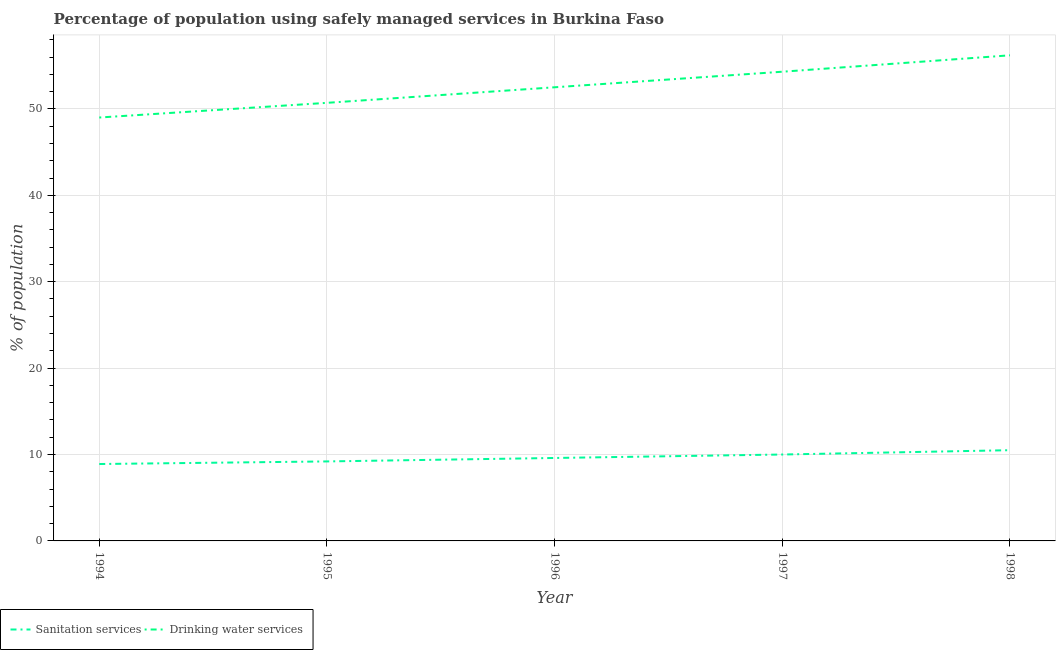How many different coloured lines are there?
Make the answer very short. 2. Across all years, what is the minimum percentage of population who used drinking water services?
Keep it short and to the point. 49. In which year was the percentage of population who used sanitation services maximum?
Your response must be concise. 1998. In which year was the percentage of population who used drinking water services minimum?
Your response must be concise. 1994. What is the total percentage of population who used sanitation services in the graph?
Your answer should be compact. 48.2. What is the difference between the percentage of population who used sanitation services in 1997 and that in 1998?
Offer a very short reply. -0.5. What is the difference between the percentage of population who used drinking water services in 1994 and the percentage of population who used sanitation services in 1995?
Your response must be concise. 39.8. What is the average percentage of population who used sanitation services per year?
Your answer should be compact. 9.64. In the year 1994, what is the difference between the percentage of population who used sanitation services and percentage of population who used drinking water services?
Provide a short and direct response. -40.1. What is the ratio of the percentage of population who used sanitation services in 1994 to that in 1995?
Your answer should be compact. 0.97. Is the percentage of population who used sanitation services in 1997 less than that in 1998?
Ensure brevity in your answer.  Yes. What is the difference between the highest and the second highest percentage of population who used drinking water services?
Offer a very short reply. 1.9. What is the difference between the highest and the lowest percentage of population who used drinking water services?
Offer a terse response. 7.2. In how many years, is the percentage of population who used sanitation services greater than the average percentage of population who used sanitation services taken over all years?
Ensure brevity in your answer.  2. Is the sum of the percentage of population who used drinking water services in 1994 and 1995 greater than the maximum percentage of population who used sanitation services across all years?
Keep it short and to the point. Yes. Does the percentage of population who used sanitation services monotonically increase over the years?
Provide a short and direct response. Yes. Is the percentage of population who used drinking water services strictly greater than the percentage of population who used sanitation services over the years?
Your response must be concise. Yes. Is the percentage of population who used drinking water services strictly less than the percentage of population who used sanitation services over the years?
Ensure brevity in your answer.  No. How many lines are there?
Offer a terse response. 2. What is the difference between two consecutive major ticks on the Y-axis?
Provide a short and direct response. 10. Are the values on the major ticks of Y-axis written in scientific E-notation?
Your answer should be very brief. No. Does the graph contain any zero values?
Offer a very short reply. No. Where does the legend appear in the graph?
Provide a short and direct response. Bottom left. How are the legend labels stacked?
Provide a succinct answer. Horizontal. What is the title of the graph?
Your answer should be very brief. Percentage of population using safely managed services in Burkina Faso. Does "International Tourists" appear as one of the legend labels in the graph?
Give a very brief answer. No. What is the label or title of the X-axis?
Make the answer very short. Year. What is the label or title of the Y-axis?
Your response must be concise. % of population. What is the % of population in Sanitation services in 1994?
Provide a succinct answer. 8.9. What is the % of population in Drinking water services in 1994?
Offer a terse response. 49. What is the % of population in Drinking water services in 1995?
Make the answer very short. 50.7. What is the % of population in Sanitation services in 1996?
Your response must be concise. 9.6. What is the % of population in Drinking water services in 1996?
Ensure brevity in your answer.  52.5. What is the % of population of Sanitation services in 1997?
Your response must be concise. 10. What is the % of population of Drinking water services in 1997?
Your response must be concise. 54.3. What is the % of population of Drinking water services in 1998?
Provide a short and direct response. 56.2. Across all years, what is the maximum % of population in Sanitation services?
Keep it short and to the point. 10.5. Across all years, what is the maximum % of population in Drinking water services?
Provide a succinct answer. 56.2. What is the total % of population of Sanitation services in the graph?
Keep it short and to the point. 48.2. What is the total % of population in Drinking water services in the graph?
Your answer should be very brief. 262.7. What is the difference between the % of population of Drinking water services in 1994 and that in 1995?
Provide a short and direct response. -1.7. What is the difference between the % of population of Drinking water services in 1994 and that in 1997?
Ensure brevity in your answer.  -5.3. What is the difference between the % of population in Sanitation services in 1995 and that in 1997?
Offer a terse response. -0.8. What is the difference between the % of population in Drinking water services in 1995 and that in 1997?
Your answer should be compact. -3.6. What is the difference between the % of population of Drinking water services in 1995 and that in 1998?
Give a very brief answer. -5.5. What is the difference between the % of population of Sanitation services in 1997 and that in 1998?
Provide a short and direct response. -0.5. What is the difference between the % of population of Sanitation services in 1994 and the % of population of Drinking water services in 1995?
Ensure brevity in your answer.  -41.8. What is the difference between the % of population of Sanitation services in 1994 and the % of population of Drinking water services in 1996?
Offer a very short reply. -43.6. What is the difference between the % of population of Sanitation services in 1994 and the % of population of Drinking water services in 1997?
Offer a very short reply. -45.4. What is the difference between the % of population in Sanitation services in 1994 and the % of population in Drinking water services in 1998?
Your response must be concise. -47.3. What is the difference between the % of population in Sanitation services in 1995 and the % of population in Drinking water services in 1996?
Your answer should be compact. -43.3. What is the difference between the % of population of Sanitation services in 1995 and the % of population of Drinking water services in 1997?
Your answer should be very brief. -45.1. What is the difference between the % of population in Sanitation services in 1995 and the % of population in Drinking water services in 1998?
Give a very brief answer. -47. What is the difference between the % of population in Sanitation services in 1996 and the % of population in Drinking water services in 1997?
Provide a succinct answer. -44.7. What is the difference between the % of population of Sanitation services in 1996 and the % of population of Drinking water services in 1998?
Keep it short and to the point. -46.6. What is the difference between the % of population of Sanitation services in 1997 and the % of population of Drinking water services in 1998?
Provide a short and direct response. -46.2. What is the average % of population in Sanitation services per year?
Your response must be concise. 9.64. What is the average % of population of Drinking water services per year?
Offer a terse response. 52.54. In the year 1994, what is the difference between the % of population in Sanitation services and % of population in Drinking water services?
Offer a terse response. -40.1. In the year 1995, what is the difference between the % of population of Sanitation services and % of population of Drinking water services?
Give a very brief answer. -41.5. In the year 1996, what is the difference between the % of population in Sanitation services and % of population in Drinking water services?
Keep it short and to the point. -42.9. In the year 1997, what is the difference between the % of population in Sanitation services and % of population in Drinking water services?
Provide a succinct answer. -44.3. In the year 1998, what is the difference between the % of population in Sanitation services and % of population in Drinking water services?
Give a very brief answer. -45.7. What is the ratio of the % of population of Sanitation services in 1994 to that in 1995?
Your answer should be compact. 0.97. What is the ratio of the % of population in Drinking water services in 1994 to that in 1995?
Provide a succinct answer. 0.97. What is the ratio of the % of population in Sanitation services in 1994 to that in 1996?
Keep it short and to the point. 0.93. What is the ratio of the % of population in Sanitation services in 1994 to that in 1997?
Make the answer very short. 0.89. What is the ratio of the % of population of Drinking water services in 1994 to that in 1997?
Keep it short and to the point. 0.9. What is the ratio of the % of population of Sanitation services in 1994 to that in 1998?
Give a very brief answer. 0.85. What is the ratio of the % of population of Drinking water services in 1994 to that in 1998?
Provide a succinct answer. 0.87. What is the ratio of the % of population in Drinking water services in 1995 to that in 1996?
Offer a very short reply. 0.97. What is the ratio of the % of population of Sanitation services in 1995 to that in 1997?
Your answer should be compact. 0.92. What is the ratio of the % of population of Drinking water services in 1995 to that in 1997?
Ensure brevity in your answer.  0.93. What is the ratio of the % of population in Sanitation services in 1995 to that in 1998?
Your answer should be compact. 0.88. What is the ratio of the % of population of Drinking water services in 1995 to that in 1998?
Your answer should be compact. 0.9. What is the ratio of the % of population of Drinking water services in 1996 to that in 1997?
Offer a very short reply. 0.97. What is the ratio of the % of population of Sanitation services in 1996 to that in 1998?
Offer a very short reply. 0.91. What is the ratio of the % of population of Drinking water services in 1996 to that in 1998?
Your answer should be very brief. 0.93. What is the ratio of the % of population of Sanitation services in 1997 to that in 1998?
Provide a short and direct response. 0.95. What is the ratio of the % of population in Drinking water services in 1997 to that in 1998?
Provide a succinct answer. 0.97. What is the difference between the highest and the second highest % of population in Drinking water services?
Offer a terse response. 1.9. 